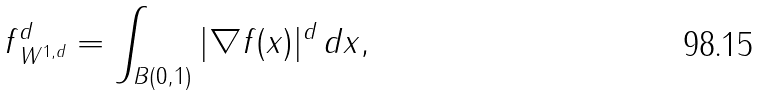Convert formula to latex. <formula><loc_0><loc_0><loc_500><loc_500>\| f \| _ { W ^ { 1 , d } } ^ { d } = \int _ { B ( 0 , 1 ) } | \nabla f ( x ) | ^ { d } \, d x ,</formula> 